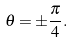Convert formula to latex. <formula><loc_0><loc_0><loc_500><loc_500>\theta = \pm \frac { \pi } { 4 } .</formula> 